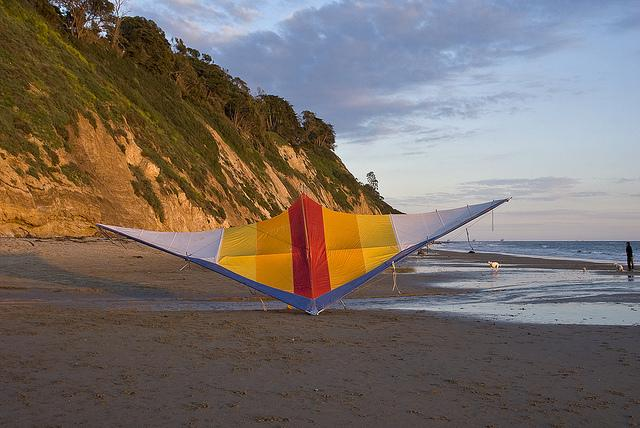What color is in the middle of the kite? Please explain your reasoning. red. There is a red stripe in the middle of the kite. 